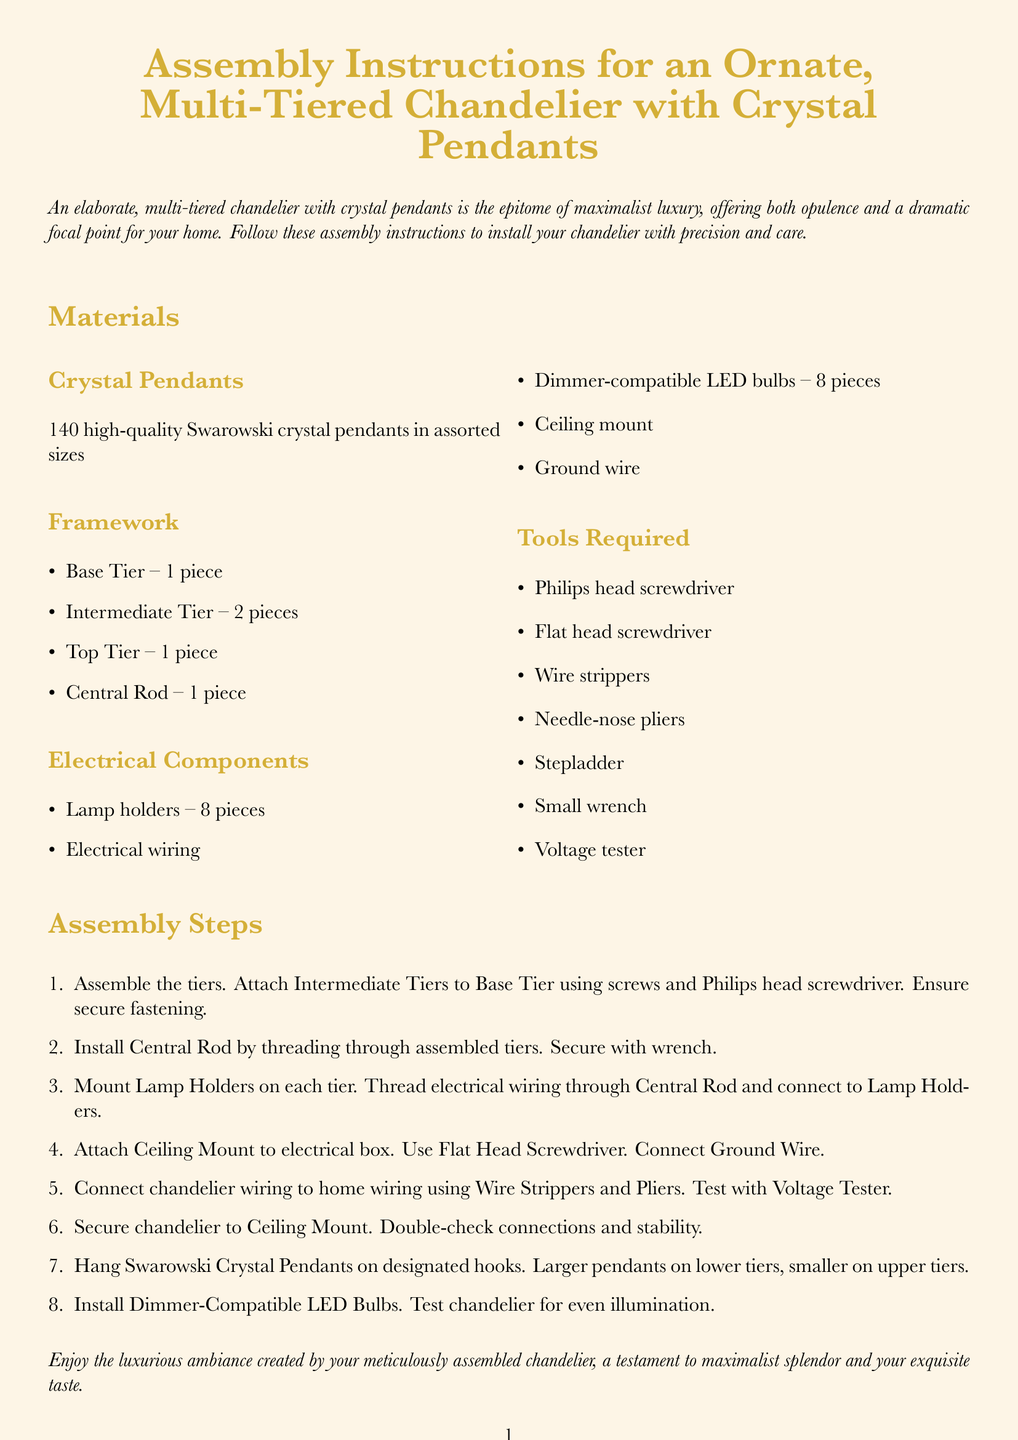what is the total number of crystal pendants? The total number of crystal pendants listed in the document is 140.
Answer: 140 how many lamp holders are included? The document specifies that there are 8 lamp holders included.
Answer: 8 what tool is required to tighten connections? The small wrench is mentioned as a tool required for tightening connections.
Answer: small wrench how many tiers does the chandelier have? The chandelier has three tiers: one base tier, two intermediate tiers, and one top tier.
Answer: three what is the main color theme of the document? The main color theme reflected in the document is gold and cream.
Answer: gold and cream which size crystals go on the lower tiers? Larger pendants are specified to go on the lower tiers of the chandelier.
Answer: larger pendants which step involves connecting the ground wire? The step involving attaching the Ceiling Mount to the electrical box includes connecting the Ground Wire.
Answer: fifth step what should be used to test the chandelier's wiring? A Voltage Tester should be used to test the chandelier's wiring connections.
Answer: Voltage Tester how are the intermediate tiers attached to the base tier? The intermediate tiers are attached to the base tier using screws.
Answer: screws 